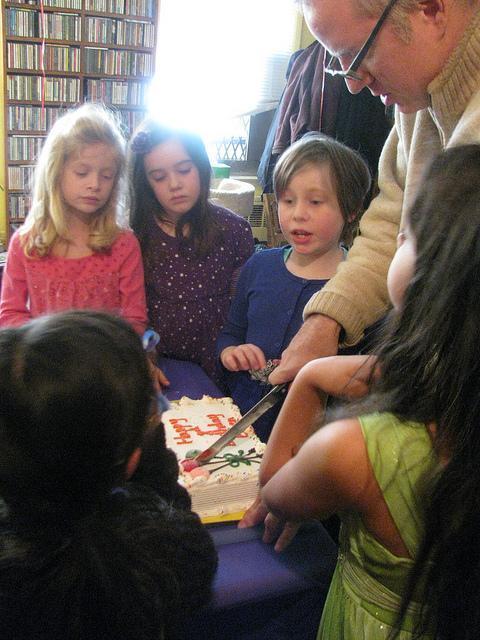How many children in the photo?
Give a very brief answer. 5. How many people can be seen?
Give a very brief answer. 6. 